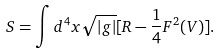<formula> <loc_0><loc_0><loc_500><loc_500>S = \int d ^ { 4 } x \sqrt { | g | } [ R - \frac { 1 } { 4 } F ^ { 2 } ( V ) ] .</formula> 